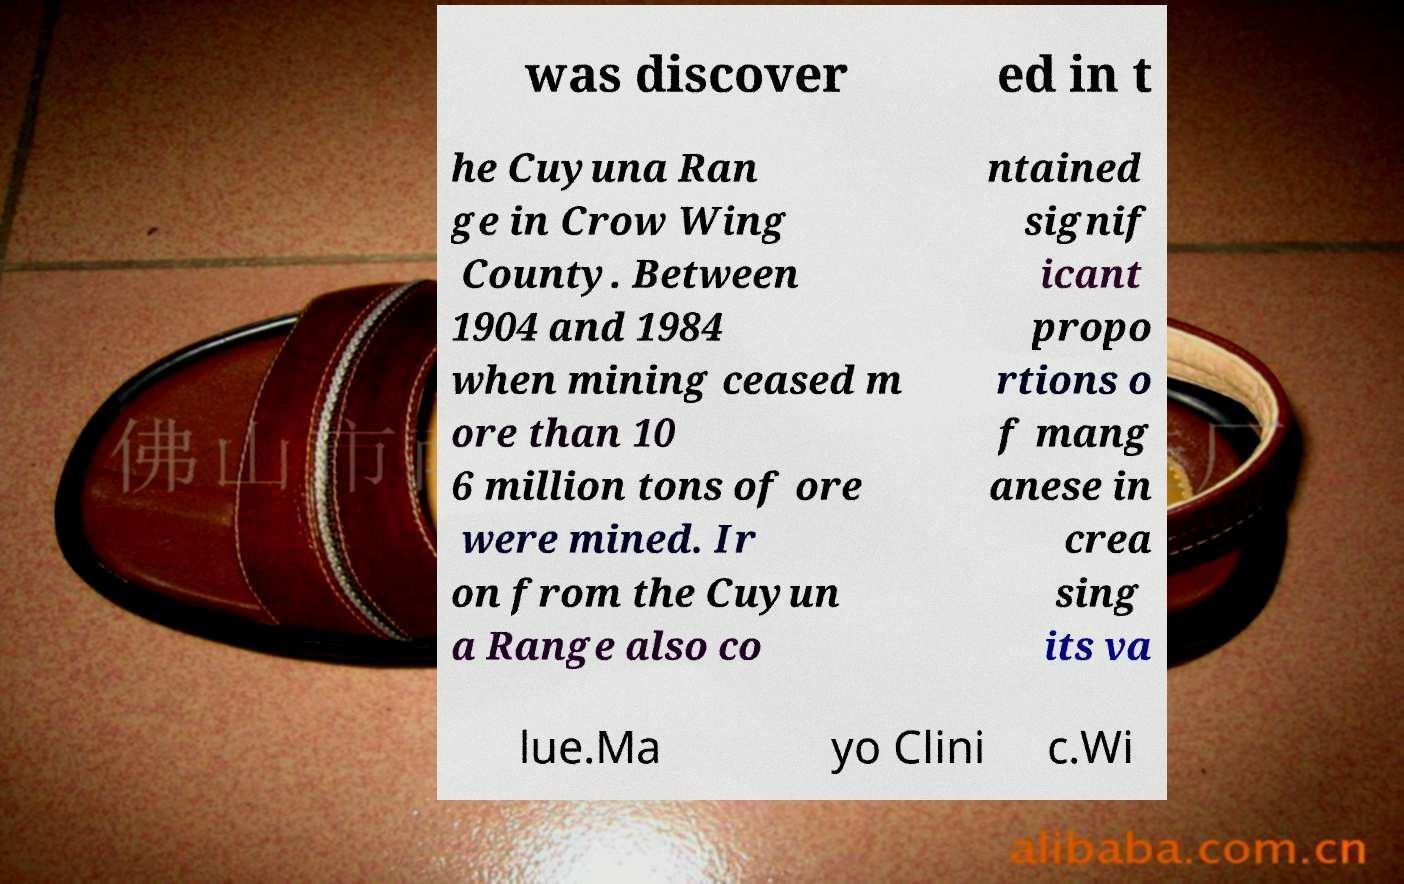Can you read and provide the text displayed in the image?This photo seems to have some interesting text. Can you extract and type it out for me? was discover ed in t he Cuyuna Ran ge in Crow Wing County. Between 1904 and 1984 when mining ceased m ore than 10 6 million tons of ore were mined. Ir on from the Cuyun a Range also co ntained signif icant propo rtions o f mang anese in crea sing its va lue.Ma yo Clini c.Wi 